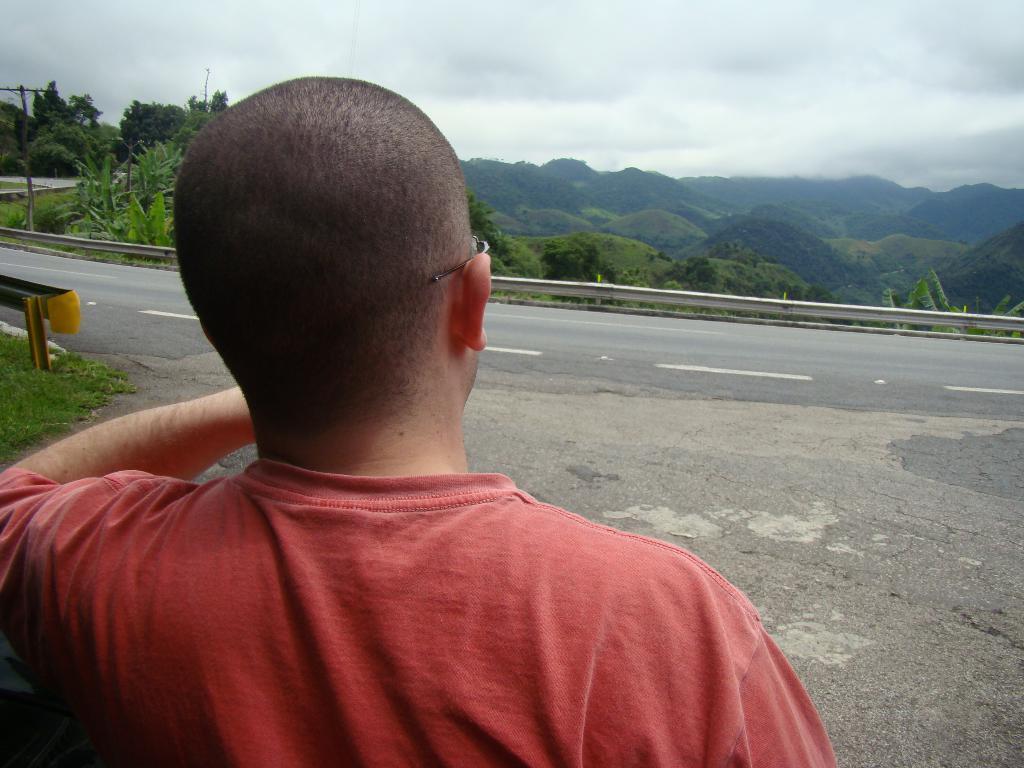How would you summarize this image in a sentence or two? In front of the image there is a person standing on the road. In the background of the image there are current polls, plants, trees. There are mountains and sky. 